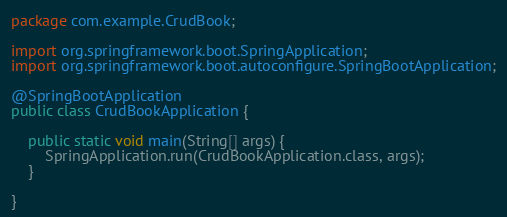<code> <loc_0><loc_0><loc_500><loc_500><_Java_>package com.example.CrudBook;

import org.springframework.boot.SpringApplication;
import org.springframework.boot.autoconfigure.SpringBootApplication;

@SpringBootApplication
public class CrudBookApplication {

    public static void main(String[] args) {
        SpringApplication.run(CrudBookApplication.class, args);
    }

}
</code> 